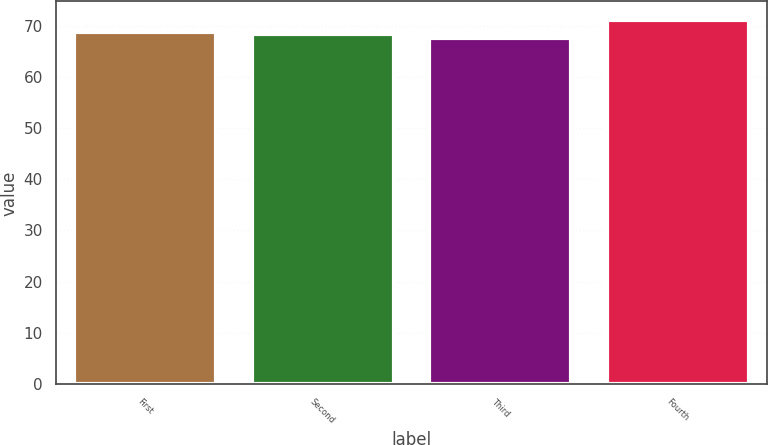Convert chart. <chart><loc_0><loc_0><loc_500><loc_500><bar_chart><fcel>First<fcel>Second<fcel>Third<fcel>Fourth<nl><fcel>68.81<fcel>68.38<fcel>67.64<fcel>71.15<nl></chart> 